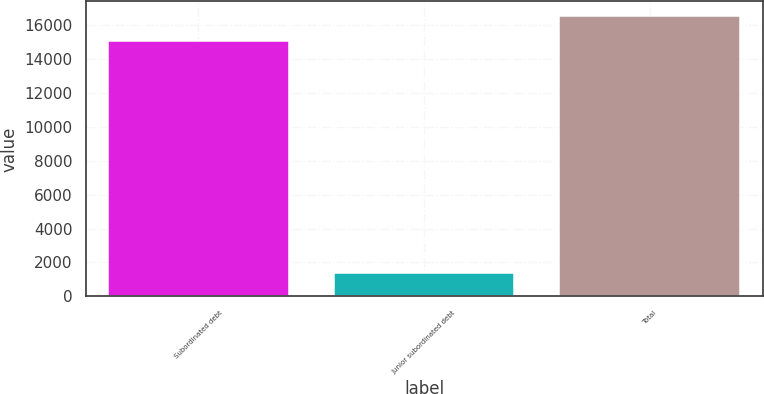<chart> <loc_0><loc_0><loc_500><loc_500><bar_chart><fcel>Subordinated debt<fcel>Junior subordinated debt<fcel>Total<nl><fcel>15058<fcel>1360<fcel>16563.8<nl></chart> 